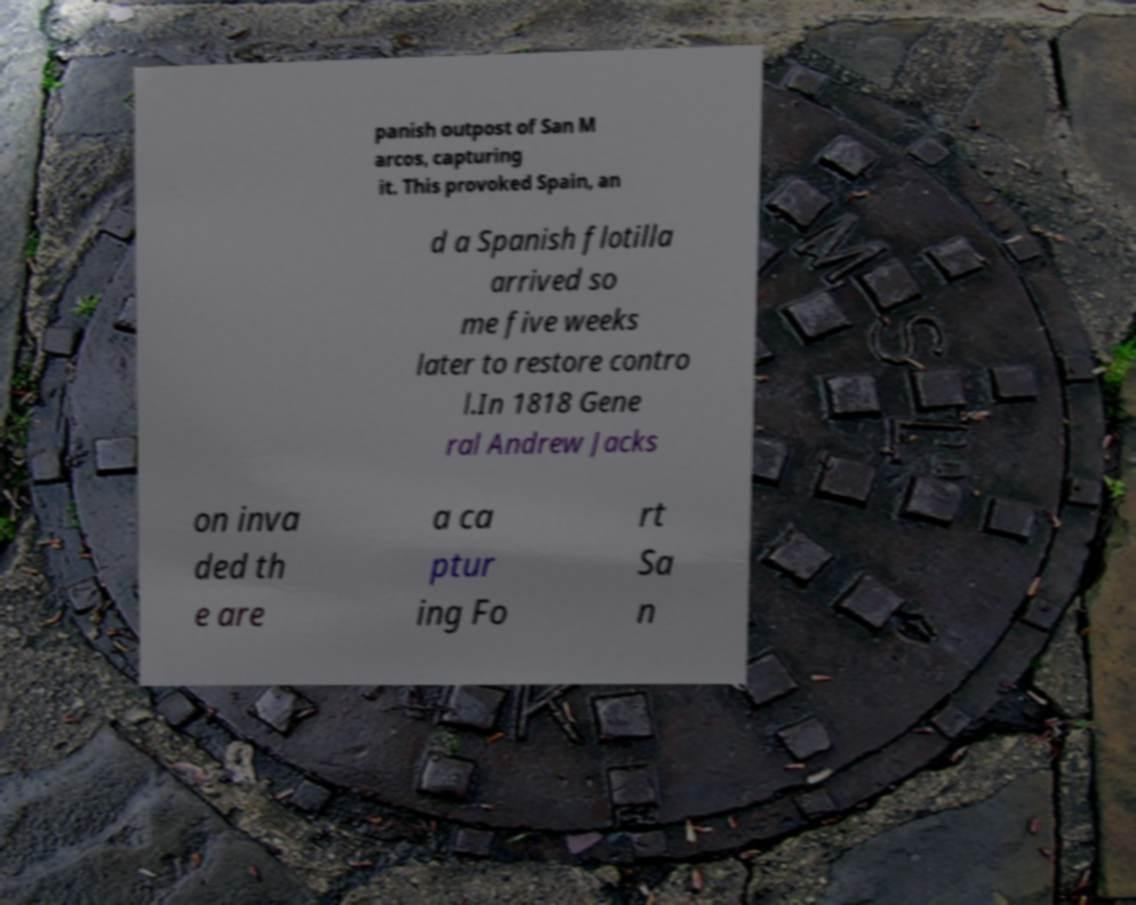Could you assist in decoding the text presented in this image and type it out clearly? panish outpost of San M arcos, capturing it. This provoked Spain, an d a Spanish flotilla arrived so me five weeks later to restore contro l.In 1818 Gene ral Andrew Jacks on inva ded th e are a ca ptur ing Fo rt Sa n 